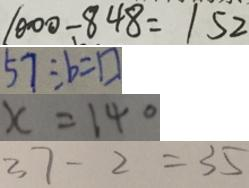Convert formula to latex. <formula><loc_0><loc_0><loc_500><loc_500>1 0 0 0 - 8 4 8 = 1 5 2 
 5 7 \div b = \square 
 x = 1 4 0 
 3 7 - 2 = 3 5</formula> 